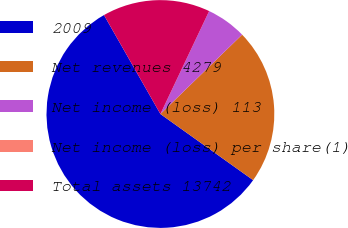<chart> <loc_0><loc_0><loc_500><loc_500><pie_chart><fcel>2009<fcel>Net revenues 4279<fcel>Net income (loss) 113<fcel>Net income (loss) per share(1)<fcel>Total assets 13742<nl><fcel>56.89%<fcel>22.13%<fcel>5.69%<fcel>0.0%<fcel>15.29%<nl></chart> 